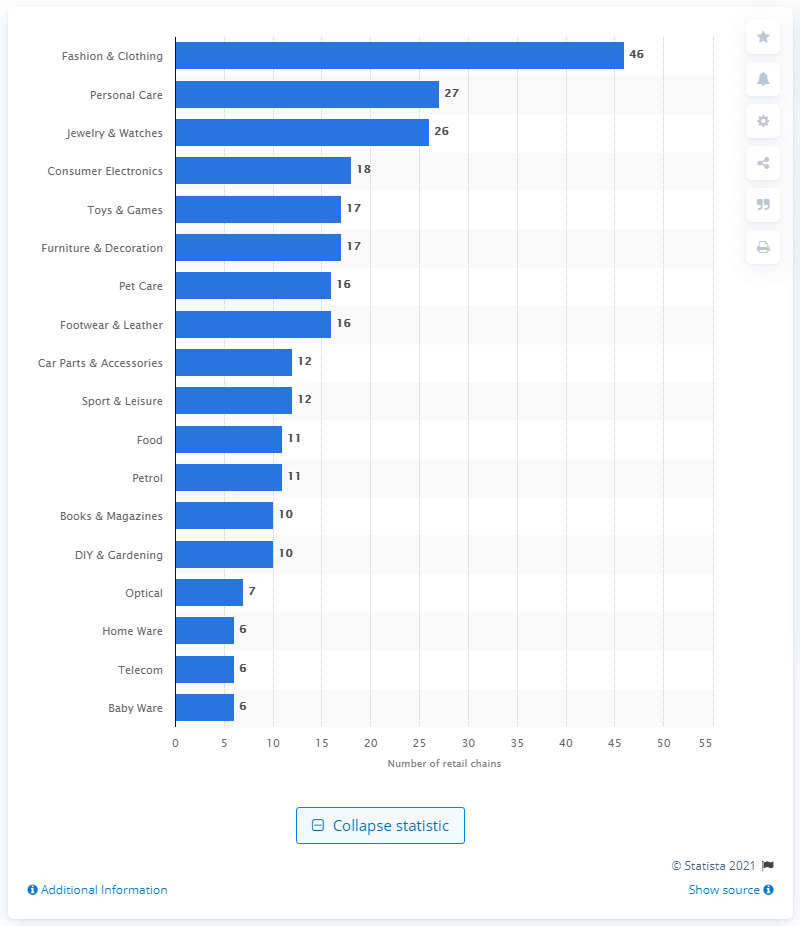Draw attention to some important aspects in this diagram. It is estimated that there are approximately 27 retail chains in the personal care industry. There were 26 retail chains in the jewelry and watches industry in Switzerland in the year 2020. 